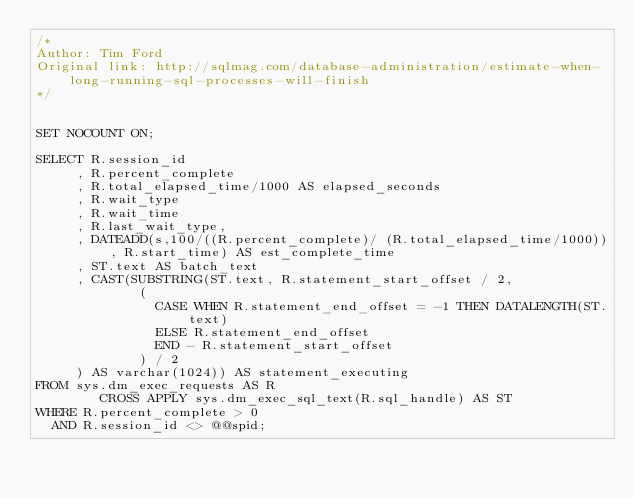Convert code to text. <code><loc_0><loc_0><loc_500><loc_500><_SQL_>/*
Author: Tim Ford
Original link: http://sqlmag.com/database-administration/estimate-when-long-running-sql-processes-will-finish
*/


SET NOCOUNT ON;

SELECT R.session_id
     , R.percent_complete
     , R.total_elapsed_time/1000 AS elapsed_seconds
     , R.wait_type
     , R.wait_time
     , R.last_wait_type,
     , DATEADD(s,100/((R.percent_complete)/ (R.total_elapsed_time/1000)), R.start_time) AS est_complete_time
     , ST.text AS batch_text
     , CAST(SUBSTRING(ST.text, R.statement_start_offset / 2,
             (
               CASE WHEN R.statement_end_offset = -1 THEN DATALENGTH(ST.text)
               ELSE R.statement_end_offset
               END - R.statement_start_offset 
             ) / 2 
     ) AS varchar(1024)) AS statement_executing
FROM sys.dm_exec_requests AS R
        CROSS APPLY sys.dm_exec_sql_text(R.sql_handle) AS ST
WHERE R.percent_complete > 0
  AND R.session_id <> @@spid;
</code> 